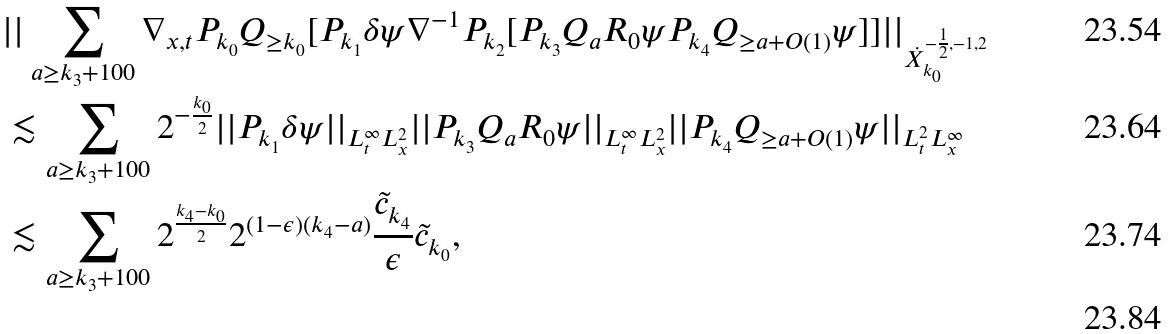<formula> <loc_0><loc_0><loc_500><loc_500>& | | \sum _ { a \geq k _ { 3 } + 1 0 0 } \nabla _ { x , t } P _ { k _ { 0 } } Q _ { \geq k _ { 0 } } [ P _ { k _ { 1 } } \delta \psi \nabla ^ { - 1 } P _ { k _ { 2 } } [ P _ { k _ { 3 } } Q _ { a } R _ { 0 } \psi P _ { k _ { 4 } } Q _ { \geq a + O ( 1 ) } \psi ] ] | | _ { \dot { X } _ { k _ { 0 } } ^ { - \frac { 1 } { 2 } , - 1 , 2 } } \\ & \lesssim \sum _ { a \geq k _ { 3 } + 1 0 0 } 2 ^ { - \frac { k _ { 0 } } { 2 } } | | P _ { k _ { 1 } } \delta \psi | | _ { L _ { t } ^ { \infty } L _ { x } ^ { 2 } } | | P _ { k _ { 3 } } Q _ { a } R _ { 0 } \psi | | _ { L _ { t } ^ { \infty } L _ { x } ^ { 2 } } | | P _ { k _ { 4 } } Q _ { \geq a + O ( 1 ) } \psi | | _ { L _ { t } ^ { 2 } L _ { x } ^ { \infty } } \\ & \lesssim \sum _ { a \geq k _ { 3 } + 1 0 0 } 2 ^ { \frac { k _ { 4 } - k _ { 0 } } { 2 } } 2 ^ { ( 1 - \epsilon ) ( k _ { 4 } - a ) } \frac { \tilde { c } _ { k _ { 4 } } } { \epsilon } \tilde { c } _ { k _ { 0 } } , \\</formula> 